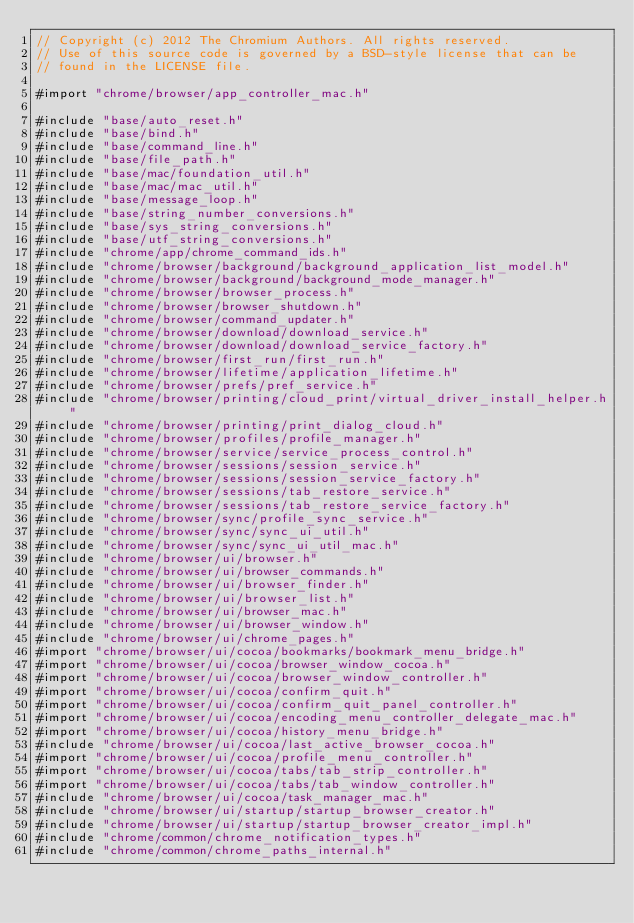Convert code to text. <code><loc_0><loc_0><loc_500><loc_500><_ObjectiveC_>// Copyright (c) 2012 The Chromium Authors. All rights reserved.
// Use of this source code is governed by a BSD-style license that can be
// found in the LICENSE file.

#import "chrome/browser/app_controller_mac.h"

#include "base/auto_reset.h"
#include "base/bind.h"
#include "base/command_line.h"
#include "base/file_path.h"
#include "base/mac/foundation_util.h"
#include "base/mac/mac_util.h"
#include "base/message_loop.h"
#include "base/string_number_conversions.h"
#include "base/sys_string_conversions.h"
#include "base/utf_string_conversions.h"
#include "chrome/app/chrome_command_ids.h"
#include "chrome/browser/background/background_application_list_model.h"
#include "chrome/browser/background/background_mode_manager.h"
#include "chrome/browser/browser_process.h"
#include "chrome/browser/browser_shutdown.h"
#include "chrome/browser/command_updater.h"
#include "chrome/browser/download/download_service.h"
#include "chrome/browser/download/download_service_factory.h"
#include "chrome/browser/first_run/first_run.h"
#include "chrome/browser/lifetime/application_lifetime.h"
#include "chrome/browser/prefs/pref_service.h"
#include "chrome/browser/printing/cloud_print/virtual_driver_install_helper.h"
#include "chrome/browser/printing/print_dialog_cloud.h"
#include "chrome/browser/profiles/profile_manager.h"
#include "chrome/browser/service/service_process_control.h"
#include "chrome/browser/sessions/session_service.h"
#include "chrome/browser/sessions/session_service_factory.h"
#include "chrome/browser/sessions/tab_restore_service.h"
#include "chrome/browser/sessions/tab_restore_service_factory.h"
#include "chrome/browser/sync/profile_sync_service.h"
#include "chrome/browser/sync/sync_ui_util.h"
#include "chrome/browser/sync/sync_ui_util_mac.h"
#include "chrome/browser/ui/browser.h"
#include "chrome/browser/ui/browser_commands.h"
#include "chrome/browser/ui/browser_finder.h"
#include "chrome/browser/ui/browser_list.h"
#include "chrome/browser/ui/browser_mac.h"
#include "chrome/browser/ui/browser_window.h"
#include "chrome/browser/ui/chrome_pages.h"
#import "chrome/browser/ui/cocoa/bookmarks/bookmark_menu_bridge.h"
#import "chrome/browser/ui/cocoa/browser_window_cocoa.h"
#import "chrome/browser/ui/cocoa/browser_window_controller.h"
#import "chrome/browser/ui/cocoa/confirm_quit.h"
#import "chrome/browser/ui/cocoa/confirm_quit_panel_controller.h"
#import "chrome/browser/ui/cocoa/encoding_menu_controller_delegate_mac.h"
#import "chrome/browser/ui/cocoa/history_menu_bridge.h"
#include "chrome/browser/ui/cocoa/last_active_browser_cocoa.h"
#import "chrome/browser/ui/cocoa/profile_menu_controller.h"
#import "chrome/browser/ui/cocoa/tabs/tab_strip_controller.h"
#import "chrome/browser/ui/cocoa/tabs/tab_window_controller.h"
#include "chrome/browser/ui/cocoa/task_manager_mac.h"
#include "chrome/browser/ui/startup/startup_browser_creator.h"
#include "chrome/browser/ui/startup/startup_browser_creator_impl.h"
#include "chrome/common/chrome_notification_types.h"
#include "chrome/common/chrome_paths_internal.h"</code> 